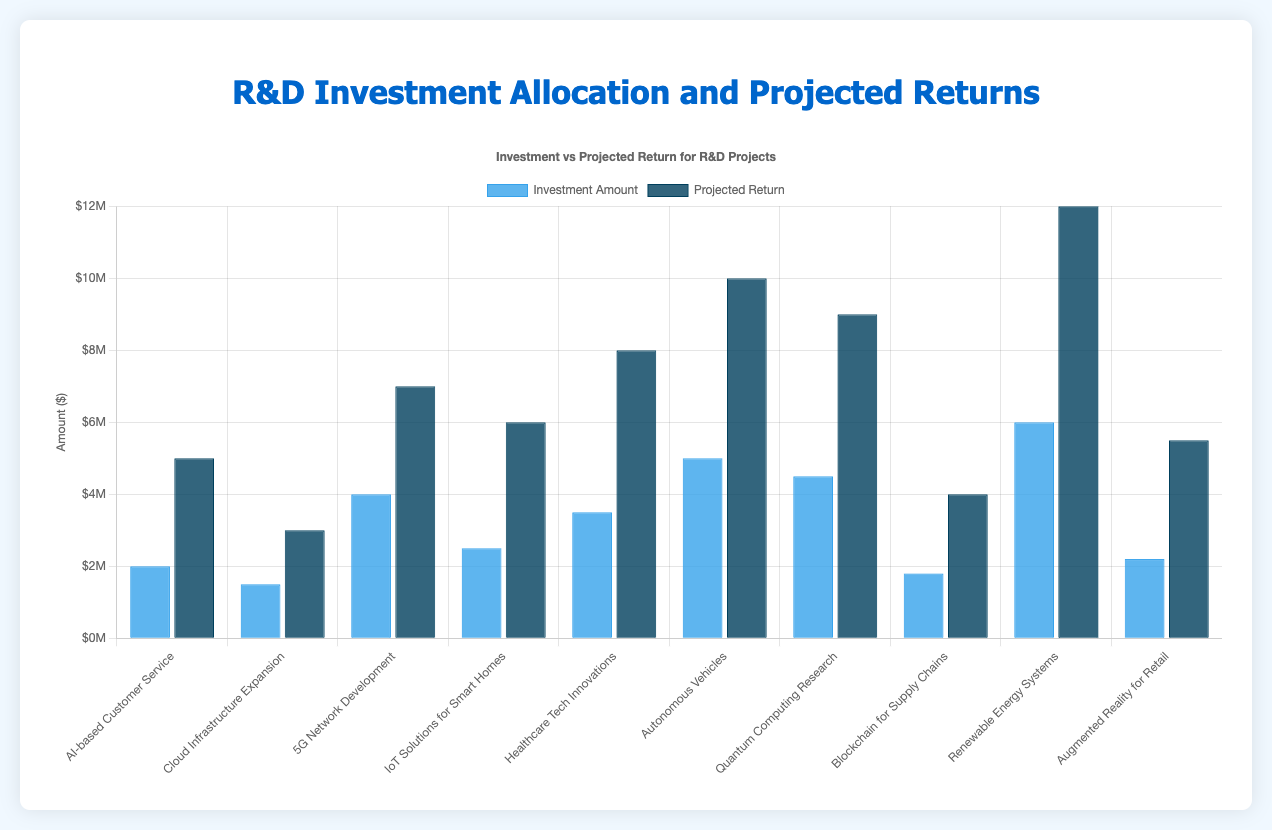Which R&D project received the highest investment? The bar representing the "Renewable Energy Systems" project has the highest height among the investment amount bars.
Answer: Renewable Energy Systems Which R&D project has the highest projected return? The bar representing the "Renewable Energy Systems" project has the highest height among the projected return bars.
Answer: Renewable Energy Systems What is the difference in investment between the "5G Network Development" and "AI-based Customer Service" projects? The investment in "5G Network Development" is $4,000,000 and "AI-based Customer Service" is $2,000,000. The difference is $4,000,000 - $2,000,000 = $2,000,000.
Answer: $2,000,000 Which project has a higher projected return: "Quantum Computing Research" or "Autonomous Vehicles"? The projected return for "Quantum Computing Research" is $9,000,000 and for "Autonomous Vehicles" is $10,000,000. The comparison shows that "Autonomous Vehicles" has a higher projected return.
Answer: Autonomous Vehicles How much more is the projected return of "Healthcare Tech Innovations" compared to its investment? The projected return of "Healthcare Tech Innovations" is $8,000,000 and the investment amount is $3,500,000. The difference is $8,000,000 - $3,500,000 = $4,500,000.
Answer: $4,500,000 What is the total investment amount for all R&D projects combined? Summing up all the investment amounts: $2,000,000 + $1,500,000 + $4,000,000 + $2,500,000 + $3,500,000 + $5,000,000 + $4,500,000 + $1,800,000 + $6,000,000 + $2,200,000 = $33,000,000.
Answer: $33,000,000 Which project has a lower projected return: "Cloud Infrastructure Expansion" or "Blockchain for Supply Chains"? The projected return for "Cloud Infrastructure Expansion" is $3,000,000 and for "Blockchain for Supply Chains" is $4,000,000. The comparison shows that "Cloud Infrastructure Expansion" has a lower projected return.
Answer: Cloud Infrastructure Expansion What is the average projected return of the projects? Summing up all projected returns: $5,000,000 + $3,000,000 + $7,000,000 + $6,000,000 + $8,000,000 + $10,000,000 + $9,000,000 + $4,000,000 + $12,000,000 + $5,500,000 equals $69,500,000. Dividing by the number of projects (10) gives an average of $69,500,000 / 10 = $6,950,000.
Answer: $6,950,000 